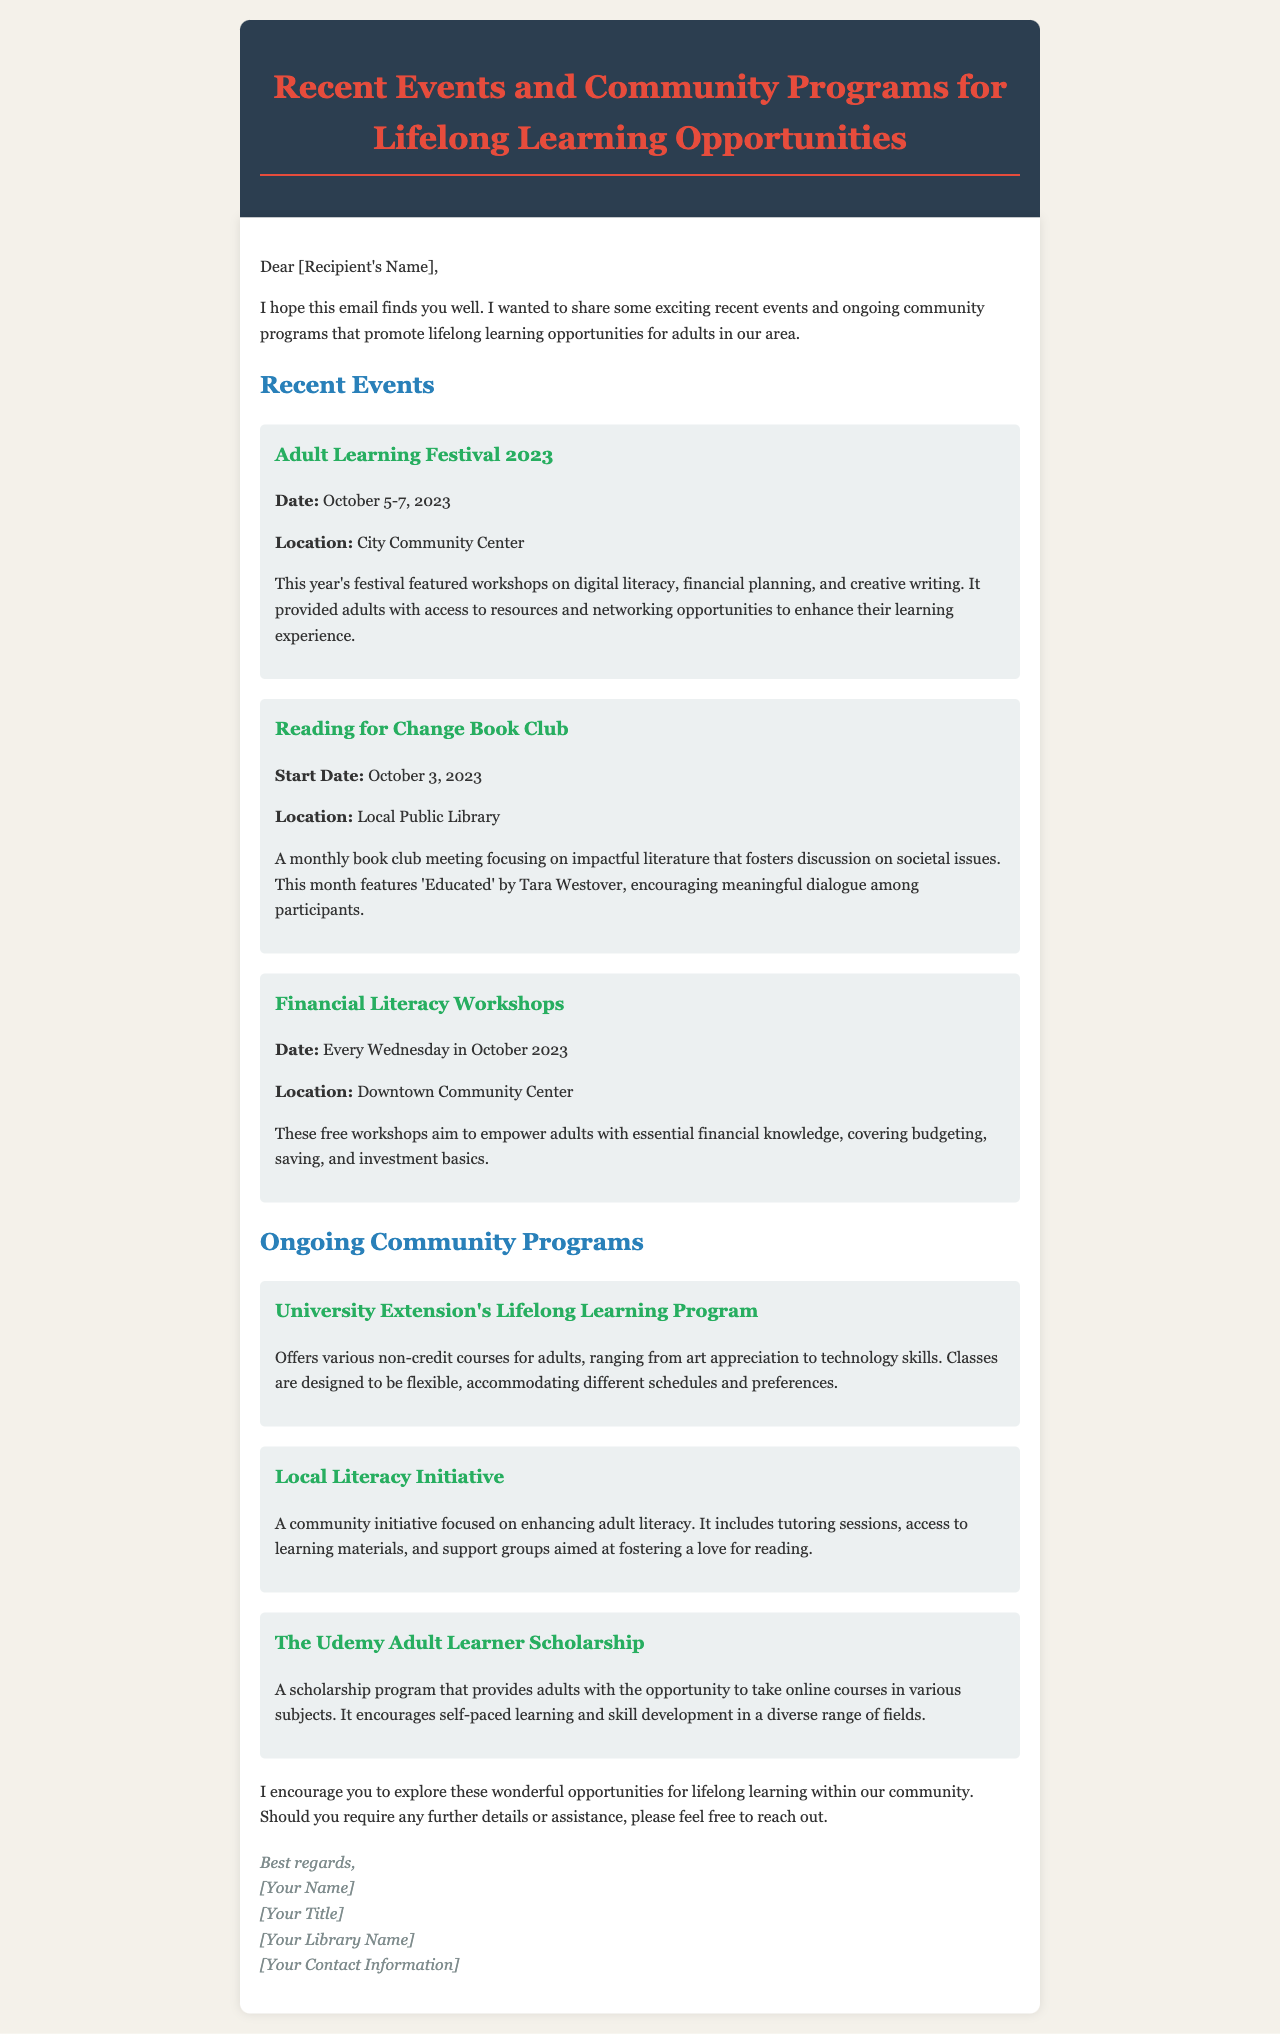What was the date of the Adult Learning Festival 2023? The date is mentioned as October 5-7, 2023.
Answer: October 5-7, 2023 Where was the Reading for Change Book Club held? The location of the book club is specified as the Local Public Library.
Answer: Local Public Library What is the focus of the Financial Literacy Workshops? The workshops are aimed at empowering adults with essential financial knowledge covering budgeting, saving, and investment basics.
Answer: Essential financial knowledge What does the University Extension's Lifelong Learning Program offer? It offers various non-credit courses for adults, ranging from art appreciation to technology skills.
Answer: Non-credit courses What is featured in this month's Reading for Change Book Club? The featured book is 'Educated' by Tara Westover, which fosters discussion on societal issues.
Answer: 'Educated' by Tara Westover How often do the Financial Literacy Workshops occur in October? The workshops are scheduled to occur every Wednesday in October 2023.
Answer: Every Wednesday Which community initiative focuses on enhancing adult literacy? The initiative is called the Local Literacy Initiative.
Answer: Local Literacy Initiative What type of learning does The Udemy Adult Learner Scholarship encourage? It encourages self-paced learning and skill development.
Answer: Self-paced learning 